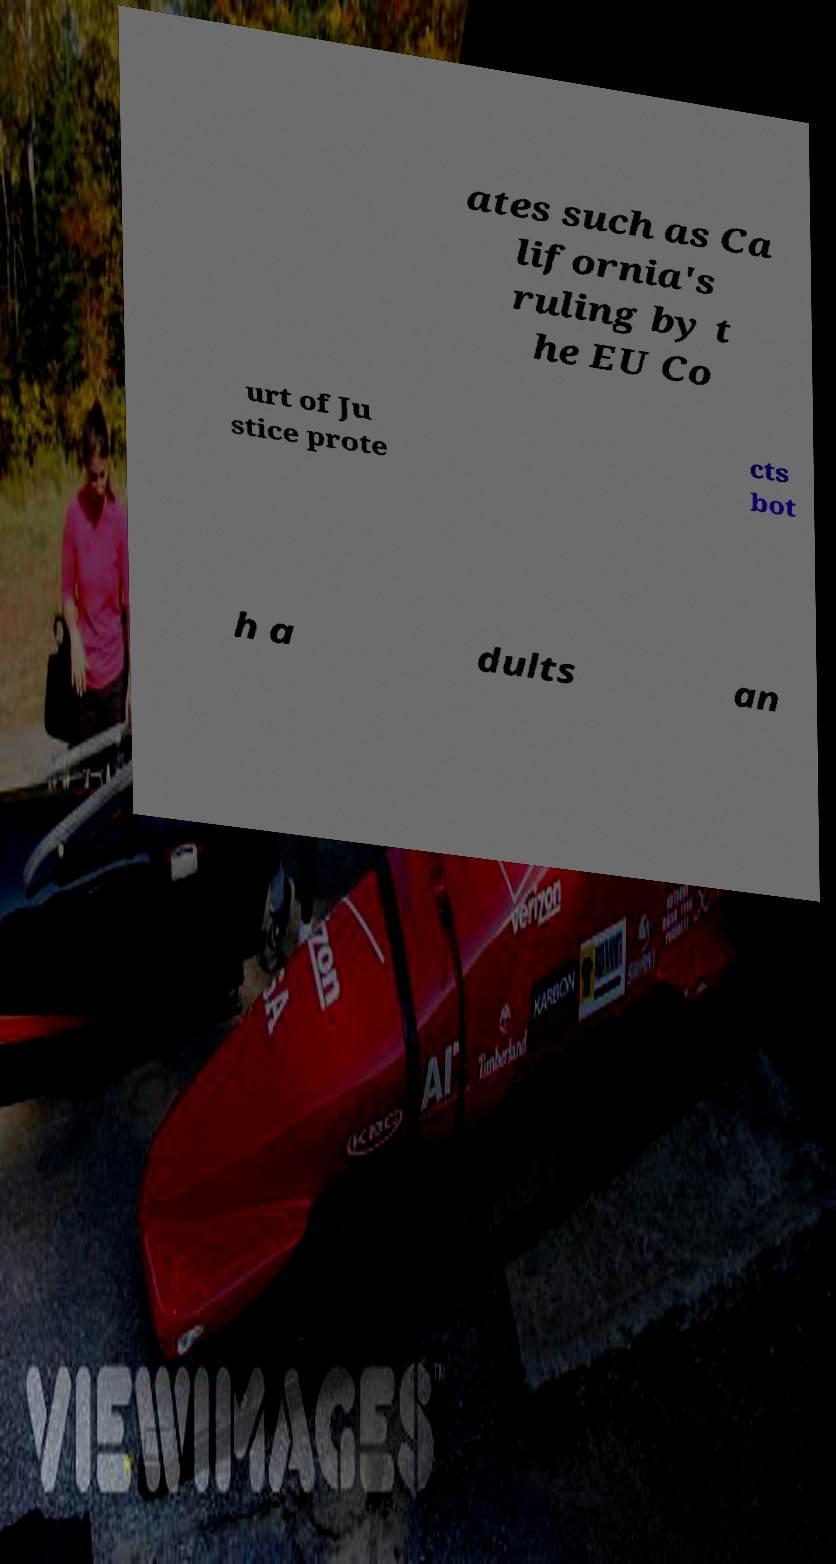What messages or text are displayed in this image? I need them in a readable, typed format. ates such as Ca lifornia's ruling by t he EU Co urt of Ju stice prote cts bot h a dults an 